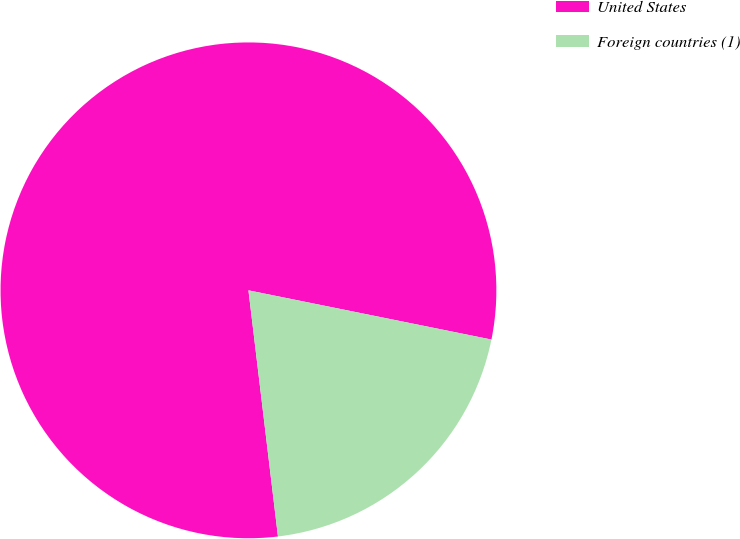Convert chart to OTSL. <chart><loc_0><loc_0><loc_500><loc_500><pie_chart><fcel>United States<fcel>Foreign countries (1)<nl><fcel>80.08%<fcel>19.92%<nl></chart> 